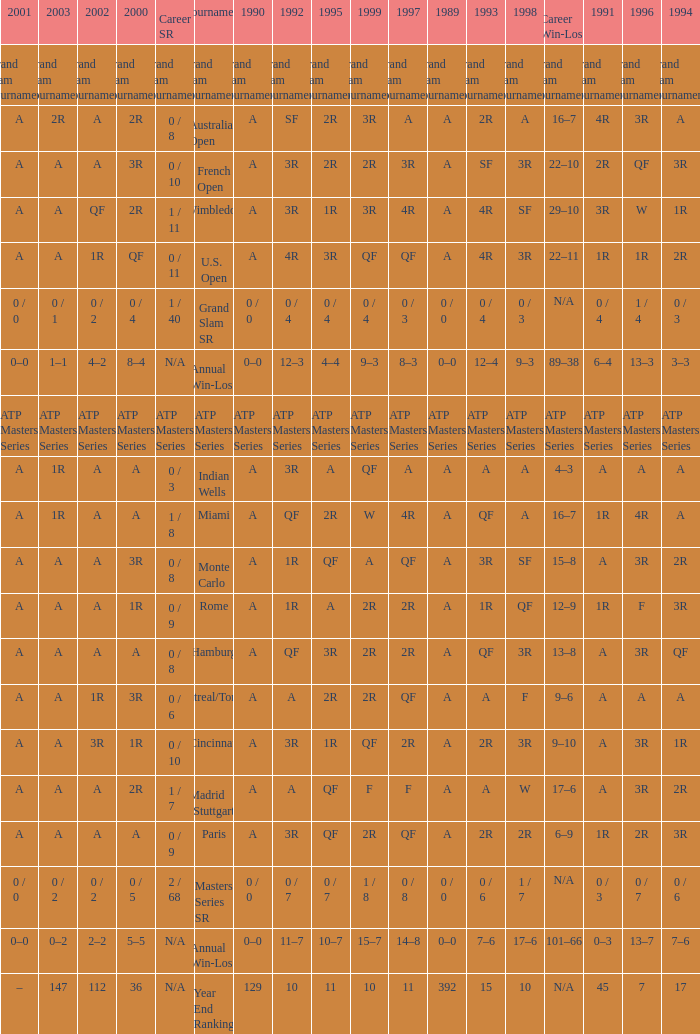If the values for 1989, 1995, and 1996 are a, qf, and 3r, respectively QF. 